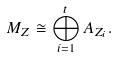Convert formula to latex. <formula><loc_0><loc_0><loc_500><loc_500>M _ { Z } \cong \bigoplus _ { i = 1 } ^ { t } A _ { Z _ { i } } .</formula> 